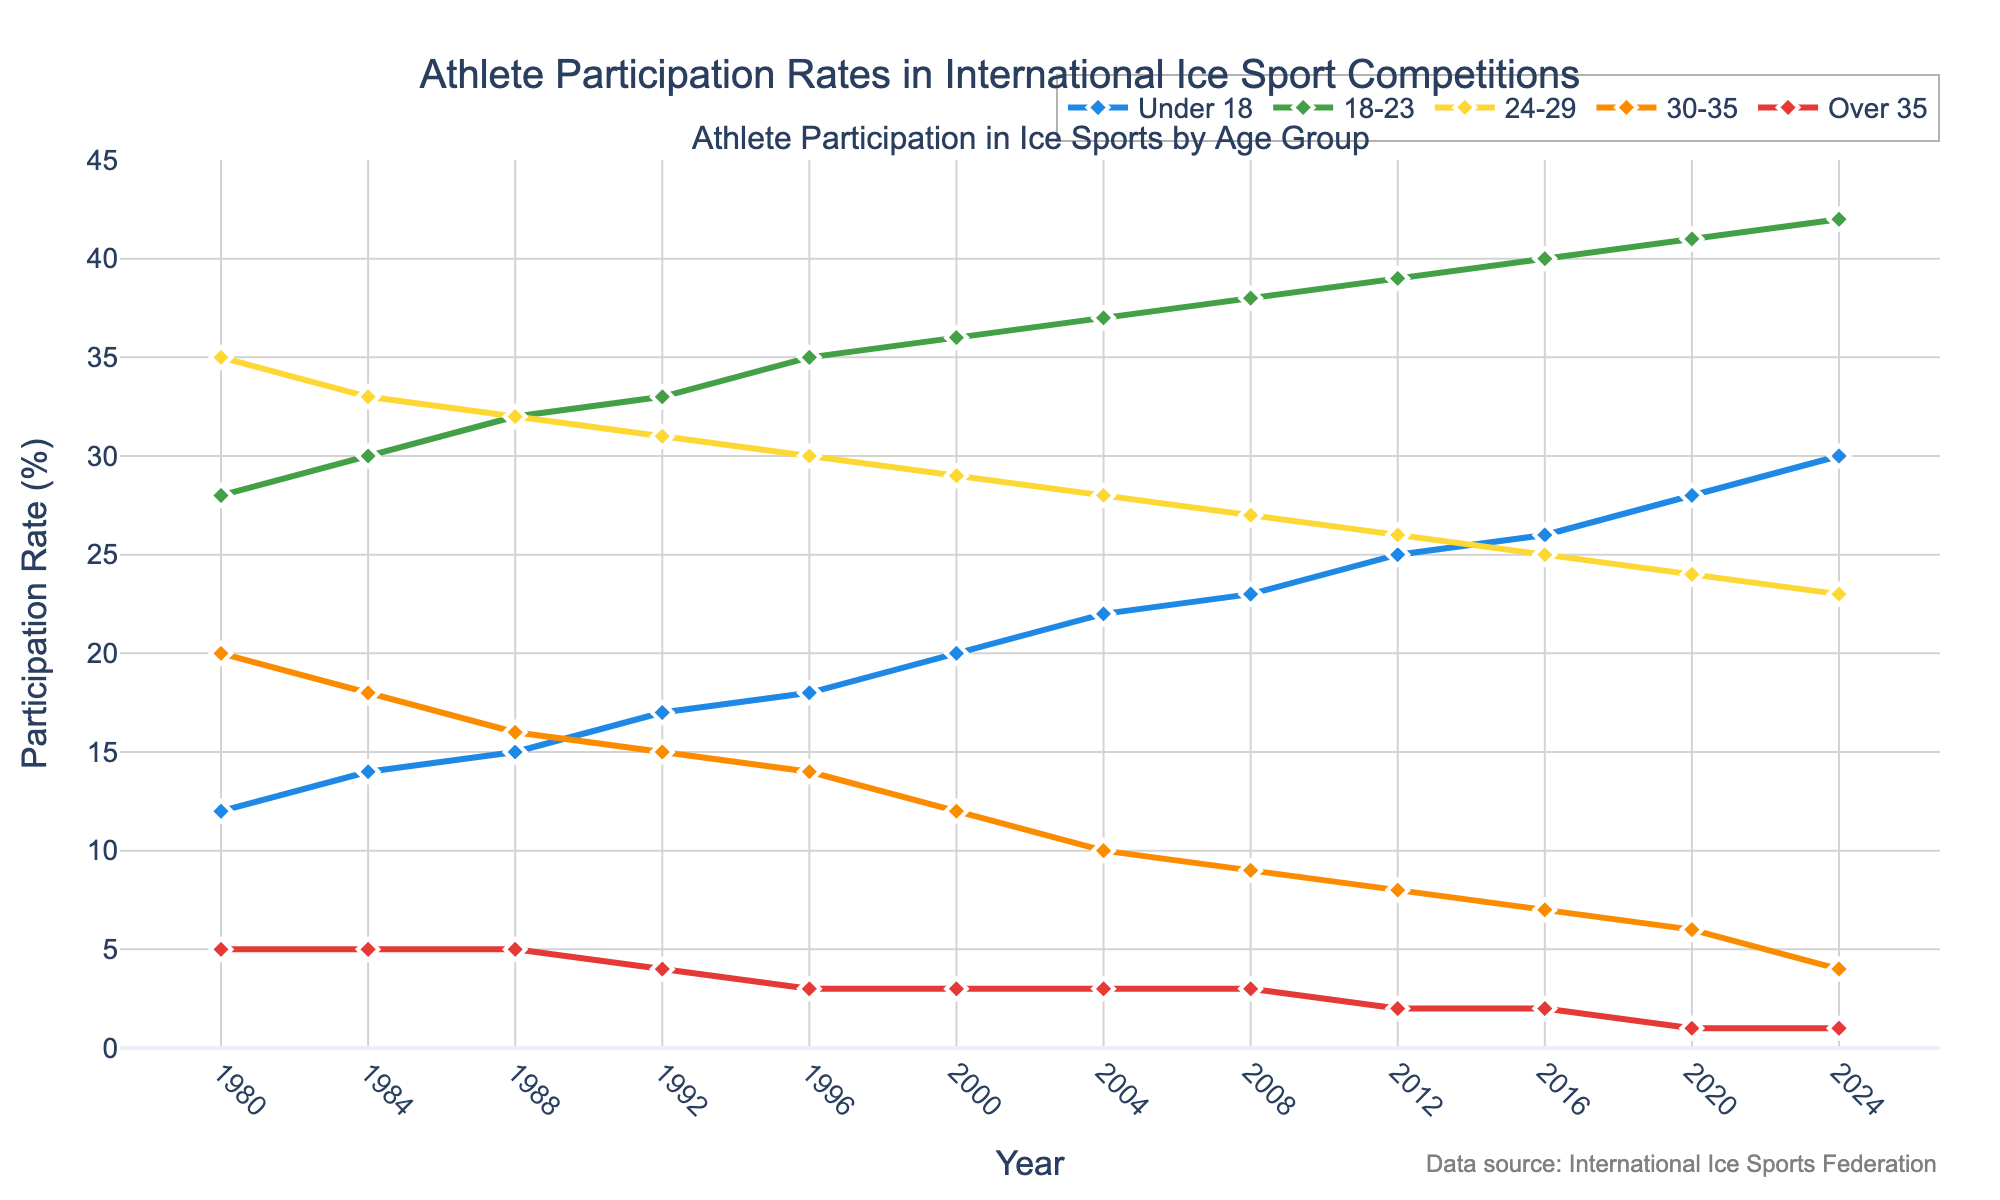What was the participation rate for the 'Under 18' age group in 1988  compared to 2008? Look at the line for 'Under 18' and find the participation rates at the points 1988 and 2008. In 1988, the rate is 15, and in 2008, it is 23. Hence, the comparison shows an increase.
Answer: 15 in 1988, 23 in 2008 By how much did the participation rate for the '18-23' age group change from 1980 to 2024? Find the '18-23' rates for the years 1980 and 2024. In 1980, it is 28, and in 2024, it is 42. The change is the difference: 42 - 28 = 14.
Answer: Increased by 14 Which age group had the highest increase in participation rates from 1980 to 2024? Calculate the difference in participation rates for each age group between 1980 and 2024. 'Under 18' increased from 12 to 30 (18), '18-23' from 28 to 42 (14), '24-29' from 35 to 23 (-12), '30-35' from 20 to 4 (-16), 'Over 35' from 5 to 1 (-4). The 'Under 18' group had the highest increase of 18.
Answer: Under 18 Which age group shows a consistently decreasing trend in participation rates over the years? Observe the general trend lines for each age group from 1980 to 2024. The '30-35' group shows a consistent decrease from 20 in 1980 to 4 in 2024.
Answer: 30-35 What is the average participation rate for the '24-29' age group over the entire period? Sum the participation rates for '24-29' from 1980 to 2024 and divide by the number of data points. The sum is 35+33+32+31+30+29+28+27+26+25+24+23 = 343. The average is 343 / 12 ≈ 28.58.
Answer: ~28.58 Between which consecutive years did the 'Over 35' age group experience its largest decrease in participation rates? Compare the 'Over 35' rates year by year. The largest drop is from 1980 (5) to 1984 (5), 1984 (5) to 1988 (5), 1988 (5) to 1992 (4), 1992 (4) to 1996 (3), repeated for each pair, 2020 (1) to 2024 (1). The significant drop pre-millennium is from 1992 (4) to 1996 (3).
Answer: 1992 to 1996 What was the participation rate for the '30-35' age group in 2012 and how does it compare to the 'Over 35' age group in the same year? Look at the data points for 2012 for both '30-35' and 'Over 35'. '30-35' has a rate of 8 and 'Over 35' has a rate of 2. The '30-35' rate is higher.
Answer: 30-35: 8, Over 35: 2 What is the difference in participation rates between 'Under 18' and '24-29' in 2000? Find the participation rates for both age groups in 2000. 'Under 18' is 20, and '24-29' is 29. The difference is 29 - 20 = 9.
Answer: 9 Which age group had the highest participation rate in 1980 and what was it? Look for the highest data point in 1980. The '24-29' age group had the highest rate of 35.
Answer: 24-29, 35 